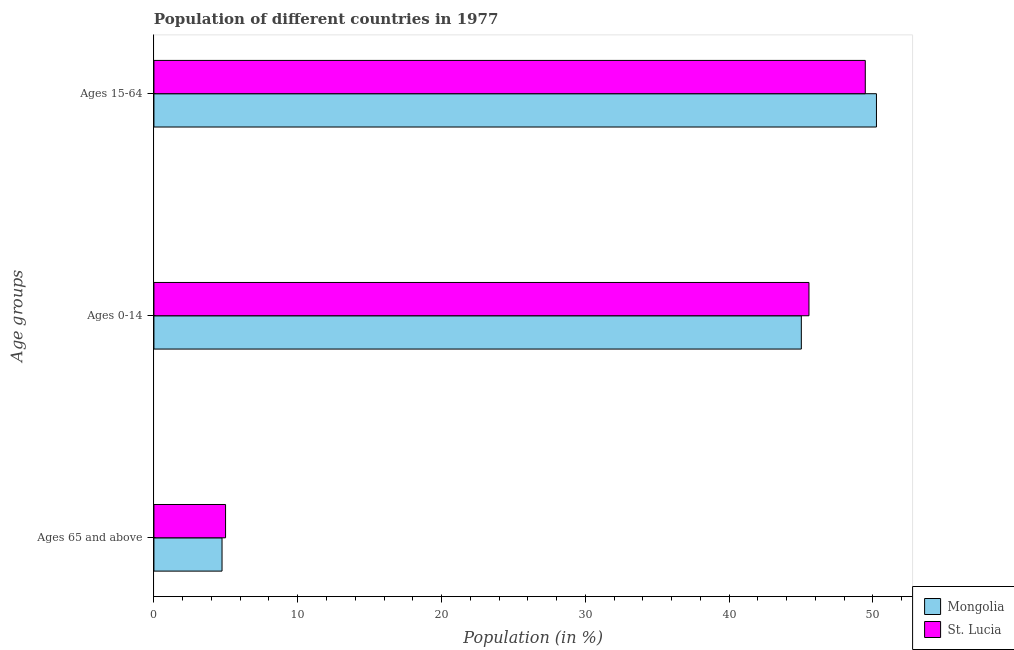How many groups of bars are there?
Offer a terse response. 3. Are the number of bars per tick equal to the number of legend labels?
Offer a terse response. Yes. What is the label of the 1st group of bars from the top?
Your answer should be very brief. Ages 15-64. What is the percentage of population within the age-group 0-14 in St. Lucia?
Keep it short and to the point. 45.55. Across all countries, what is the maximum percentage of population within the age-group 15-64?
Provide a short and direct response. 50.24. Across all countries, what is the minimum percentage of population within the age-group 15-64?
Give a very brief answer. 49.47. In which country was the percentage of population within the age-group 15-64 maximum?
Offer a very short reply. Mongolia. In which country was the percentage of population within the age-group 0-14 minimum?
Keep it short and to the point. Mongolia. What is the total percentage of population within the age-group of 65 and above in the graph?
Offer a terse response. 9.72. What is the difference between the percentage of population within the age-group 0-14 in Mongolia and that in St. Lucia?
Offer a very short reply. -0.53. What is the difference between the percentage of population within the age-group of 65 and above in Mongolia and the percentage of population within the age-group 15-64 in St. Lucia?
Your response must be concise. -44.73. What is the average percentage of population within the age-group 0-14 per country?
Give a very brief answer. 45.29. What is the difference between the percentage of population within the age-group of 65 and above and percentage of population within the age-group 15-64 in St. Lucia?
Provide a short and direct response. -44.49. What is the ratio of the percentage of population within the age-group 0-14 in St. Lucia to that in Mongolia?
Your response must be concise. 1.01. Is the percentage of population within the age-group 0-14 in St. Lucia less than that in Mongolia?
Offer a very short reply. No. Is the difference between the percentage of population within the age-group of 65 and above in Mongolia and St. Lucia greater than the difference between the percentage of population within the age-group 0-14 in Mongolia and St. Lucia?
Provide a short and direct response. Yes. What is the difference between the highest and the second highest percentage of population within the age-group 15-64?
Your answer should be very brief. 0.78. What is the difference between the highest and the lowest percentage of population within the age-group of 65 and above?
Make the answer very short. 0.25. In how many countries, is the percentage of population within the age-group 0-14 greater than the average percentage of population within the age-group 0-14 taken over all countries?
Your answer should be compact. 1. What does the 2nd bar from the top in Ages 65 and above represents?
Provide a succinct answer. Mongolia. What does the 2nd bar from the bottom in Ages 65 and above represents?
Keep it short and to the point. St. Lucia. How many bars are there?
Make the answer very short. 6. How many countries are there in the graph?
Ensure brevity in your answer.  2. Are the values on the major ticks of X-axis written in scientific E-notation?
Give a very brief answer. No. Does the graph contain any zero values?
Offer a very short reply. No. Does the graph contain grids?
Offer a terse response. No. How are the legend labels stacked?
Offer a very short reply. Vertical. What is the title of the graph?
Your answer should be compact. Population of different countries in 1977. Does "Myanmar" appear as one of the legend labels in the graph?
Your answer should be very brief. No. What is the label or title of the Y-axis?
Give a very brief answer. Age groups. What is the Population (in %) in Mongolia in Ages 65 and above?
Your response must be concise. 4.74. What is the Population (in %) of St. Lucia in Ages 65 and above?
Your answer should be very brief. 4.98. What is the Population (in %) of Mongolia in Ages 0-14?
Provide a succinct answer. 45.02. What is the Population (in %) in St. Lucia in Ages 0-14?
Offer a very short reply. 45.55. What is the Population (in %) in Mongolia in Ages 15-64?
Keep it short and to the point. 50.24. What is the Population (in %) of St. Lucia in Ages 15-64?
Offer a terse response. 49.47. Across all Age groups, what is the maximum Population (in %) of Mongolia?
Keep it short and to the point. 50.24. Across all Age groups, what is the maximum Population (in %) in St. Lucia?
Provide a short and direct response. 49.47. Across all Age groups, what is the minimum Population (in %) of Mongolia?
Ensure brevity in your answer.  4.74. Across all Age groups, what is the minimum Population (in %) in St. Lucia?
Your answer should be very brief. 4.98. What is the total Population (in %) of Mongolia in the graph?
Provide a succinct answer. 100. What is the total Population (in %) of St. Lucia in the graph?
Provide a succinct answer. 100. What is the difference between the Population (in %) in Mongolia in Ages 65 and above and that in Ages 0-14?
Make the answer very short. -40.28. What is the difference between the Population (in %) of St. Lucia in Ages 65 and above and that in Ages 0-14?
Provide a succinct answer. -40.57. What is the difference between the Population (in %) in Mongolia in Ages 65 and above and that in Ages 15-64?
Give a very brief answer. -45.51. What is the difference between the Population (in %) of St. Lucia in Ages 65 and above and that in Ages 15-64?
Give a very brief answer. -44.49. What is the difference between the Population (in %) of Mongolia in Ages 0-14 and that in Ages 15-64?
Offer a very short reply. -5.22. What is the difference between the Population (in %) of St. Lucia in Ages 0-14 and that in Ages 15-64?
Keep it short and to the point. -3.92. What is the difference between the Population (in %) in Mongolia in Ages 65 and above and the Population (in %) in St. Lucia in Ages 0-14?
Ensure brevity in your answer.  -40.82. What is the difference between the Population (in %) in Mongolia in Ages 65 and above and the Population (in %) in St. Lucia in Ages 15-64?
Provide a short and direct response. -44.73. What is the difference between the Population (in %) in Mongolia in Ages 0-14 and the Population (in %) in St. Lucia in Ages 15-64?
Make the answer very short. -4.45. What is the average Population (in %) in Mongolia per Age groups?
Provide a short and direct response. 33.33. What is the average Population (in %) of St. Lucia per Age groups?
Offer a very short reply. 33.33. What is the difference between the Population (in %) of Mongolia and Population (in %) of St. Lucia in Ages 65 and above?
Ensure brevity in your answer.  -0.25. What is the difference between the Population (in %) of Mongolia and Population (in %) of St. Lucia in Ages 0-14?
Make the answer very short. -0.53. What is the difference between the Population (in %) in Mongolia and Population (in %) in St. Lucia in Ages 15-64?
Your response must be concise. 0.78. What is the ratio of the Population (in %) of Mongolia in Ages 65 and above to that in Ages 0-14?
Make the answer very short. 0.11. What is the ratio of the Population (in %) in St. Lucia in Ages 65 and above to that in Ages 0-14?
Your answer should be compact. 0.11. What is the ratio of the Population (in %) in Mongolia in Ages 65 and above to that in Ages 15-64?
Keep it short and to the point. 0.09. What is the ratio of the Population (in %) in St. Lucia in Ages 65 and above to that in Ages 15-64?
Make the answer very short. 0.1. What is the ratio of the Population (in %) in Mongolia in Ages 0-14 to that in Ages 15-64?
Offer a very short reply. 0.9. What is the ratio of the Population (in %) of St. Lucia in Ages 0-14 to that in Ages 15-64?
Your answer should be very brief. 0.92. What is the difference between the highest and the second highest Population (in %) in Mongolia?
Offer a terse response. 5.22. What is the difference between the highest and the second highest Population (in %) in St. Lucia?
Provide a short and direct response. 3.92. What is the difference between the highest and the lowest Population (in %) in Mongolia?
Make the answer very short. 45.51. What is the difference between the highest and the lowest Population (in %) in St. Lucia?
Give a very brief answer. 44.49. 